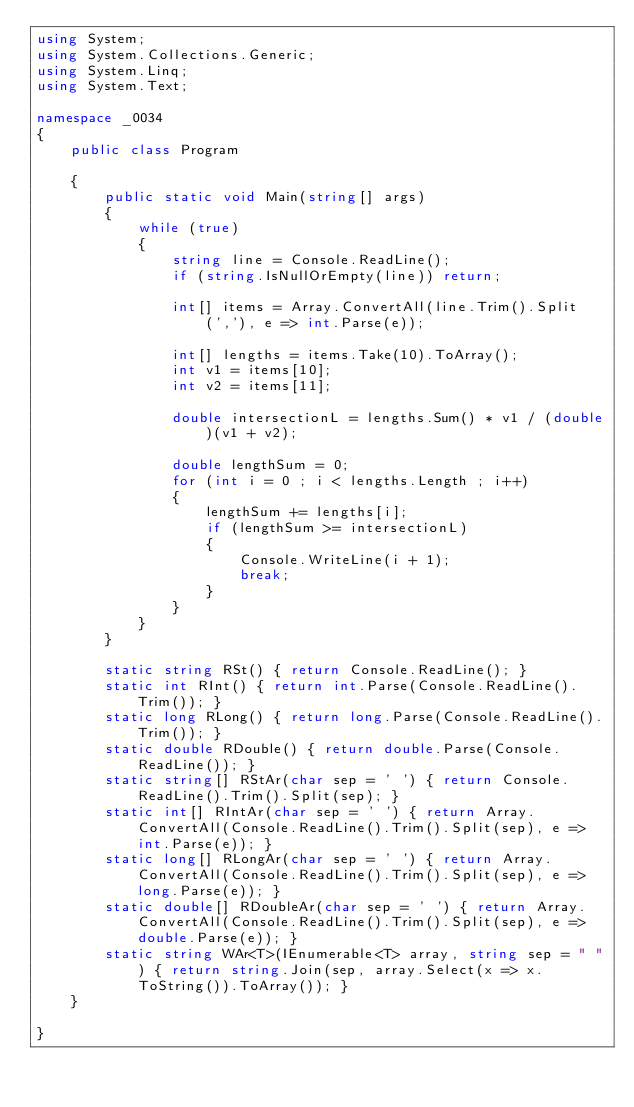Convert code to text. <code><loc_0><loc_0><loc_500><loc_500><_C#_>using System;
using System.Collections.Generic;
using System.Linq;
using System.Text;

namespace _0034
{
    public class Program

    {
        public static void Main(string[] args)
        {
            while (true)
            {
                string line = Console.ReadLine();
                if (string.IsNullOrEmpty(line)) return;

                int[] items = Array.ConvertAll(line.Trim().Split(','), e => int.Parse(e));

                int[] lengths = items.Take(10).ToArray();
                int v1 = items[10];
                int v2 = items[11];

                double intersectionL = lengths.Sum() * v1 / (double)(v1 + v2);

                double lengthSum = 0;
                for (int i = 0 ; i < lengths.Length ; i++)
                {
                    lengthSum += lengths[i];
                    if (lengthSum >= intersectionL)
                    {
                        Console.WriteLine(i + 1);
                        break;
                    }
                }
            }
        }

        static string RSt() { return Console.ReadLine(); }
        static int RInt() { return int.Parse(Console.ReadLine().Trim()); }
        static long RLong() { return long.Parse(Console.ReadLine().Trim()); }
        static double RDouble() { return double.Parse(Console.ReadLine()); }
        static string[] RStAr(char sep = ' ') { return Console.ReadLine().Trim().Split(sep); }
        static int[] RIntAr(char sep = ' ') { return Array.ConvertAll(Console.ReadLine().Trim().Split(sep), e => int.Parse(e)); }
        static long[] RLongAr(char sep = ' ') { return Array.ConvertAll(Console.ReadLine().Trim().Split(sep), e => long.Parse(e)); }
        static double[] RDoubleAr(char sep = ' ') { return Array.ConvertAll(Console.ReadLine().Trim().Split(sep), e => double.Parse(e)); }
        static string WAr<T>(IEnumerable<T> array, string sep = " ") { return string.Join(sep, array.Select(x => x.ToString()).ToArray()); }
    }

}

</code> 